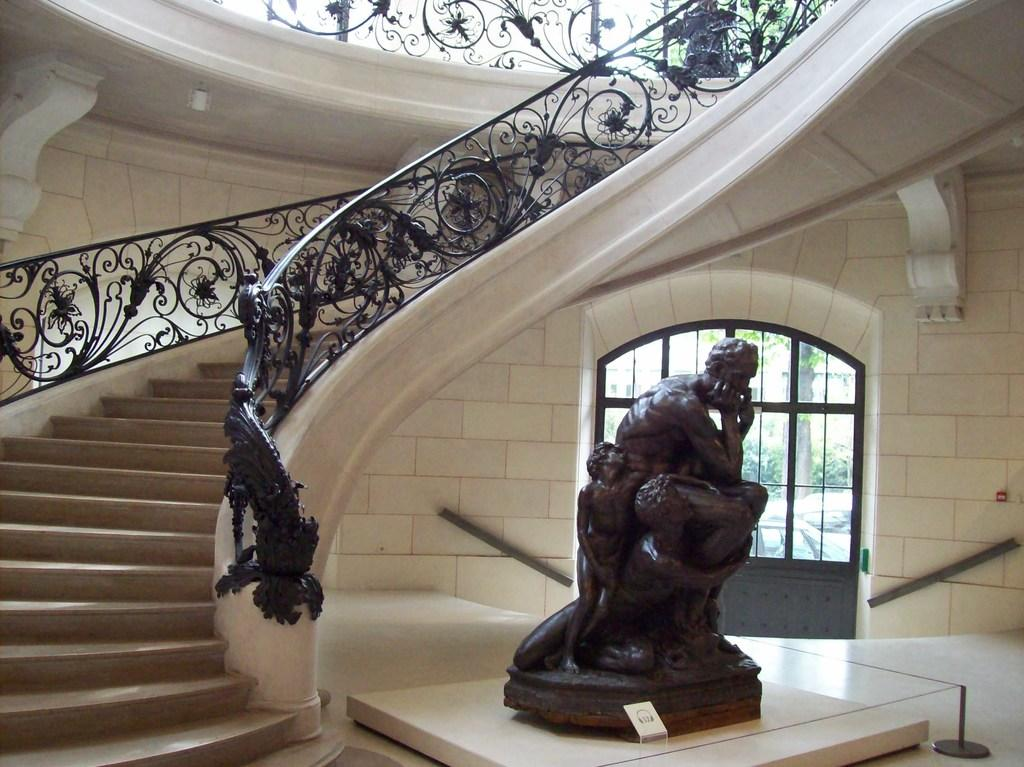What is the main subject of the image? There is a statue in the image. What is the statue standing on? The statue is on a white surface. What can be seen in the background of the image? There are windows, a wall, and other objects in the background of the image. Are there any architectural features in the image? Yes, there are steps and a fence in the image. Can you tell me how many grapes are on the statue's head in the image? There are no grapes present on the statue's head in the image. What type of nest can be seen in the image? There is no nest present in the image. 